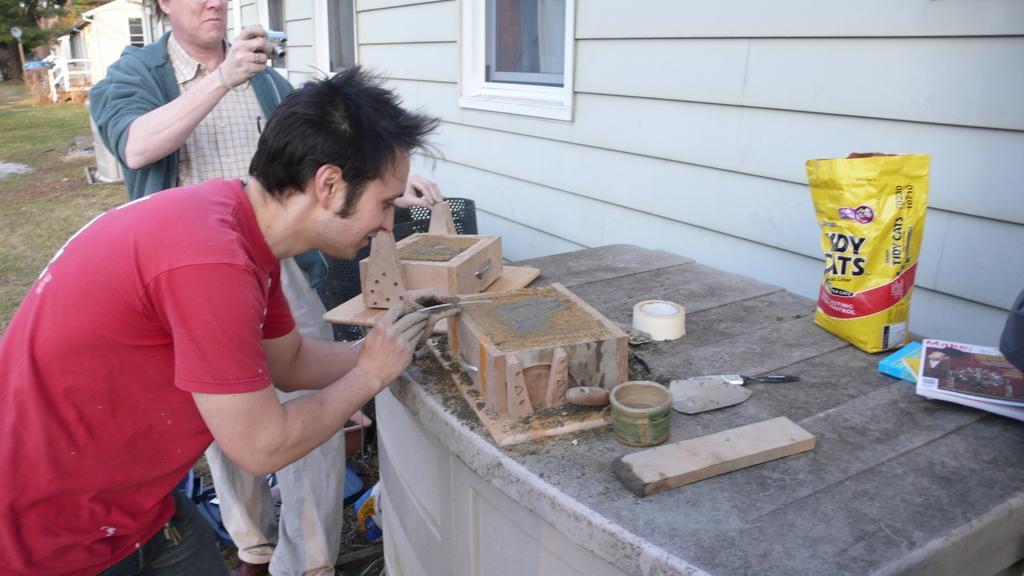Could you give a brief overview of what you see in this image? In this picture we can see a packet, tape, books, wooden objects, camera, houses, windows, grass and some objects and two people standing and in the background we can see trees. 